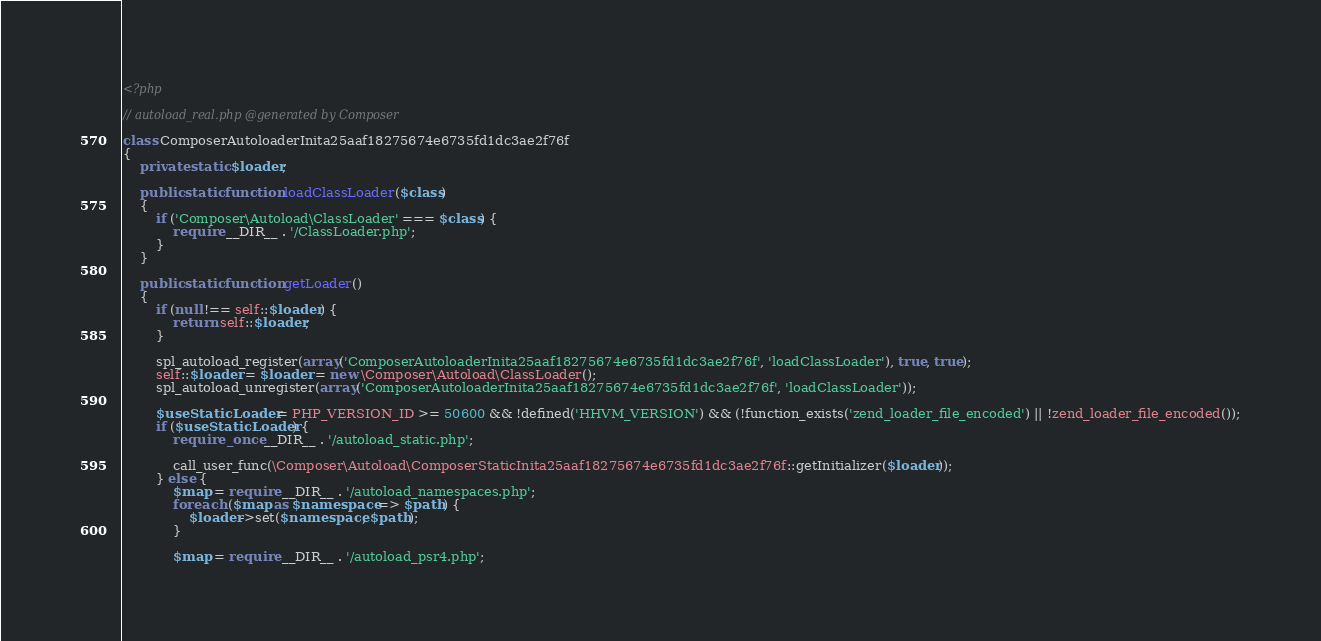Convert code to text. <code><loc_0><loc_0><loc_500><loc_500><_PHP_><?php

// autoload_real.php @generated by Composer

class ComposerAutoloaderInita25aaf18275674e6735fd1dc3ae2f76f
{
    private static $loader;

    public static function loadClassLoader($class)
    {
        if ('Composer\Autoload\ClassLoader' === $class) {
            require __DIR__ . '/ClassLoader.php';
        }
    }

    public static function getLoader()
    {
        if (null !== self::$loader) {
            return self::$loader;
        }

        spl_autoload_register(array('ComposerAutoloaderInita25aaf18275674e6735fd1dc3ae2f76f', 'loadClassLoader'), true, true);
        self::$loader = $loader = new \Composer\Autoload\ClassLoader();
        spl_autoload_unregister(array('ComposerAutoloaderInita25aaf18275674e6735fd1dc3ae2f76f', 'loadClassLoader'));

        $useStaticLoader = PHP_VERSION_ID >= 50600 && !defined('HHVM_VERSION') && (!function_exists('zend_loader_file_encoded') || !zend_loader_file_encoded());
        if ($useStaticLoader) {
            require_once __DIR__ . '/autoload_static.php';

            call_user_func(\Composer\Autoload\ComposerStaticInita25aaf18275674e6735fd1dc3ae2f76f::getInitializer($loader));
        } else {
            $map = require __DIR__ . '/autoload_namespaces.php';
            foreach ($map as $namespace => $path) {
                $loader->set($namespace, $path);
            }

            $map = require __DIR__ . '/autoload_psr4.php';</code> 